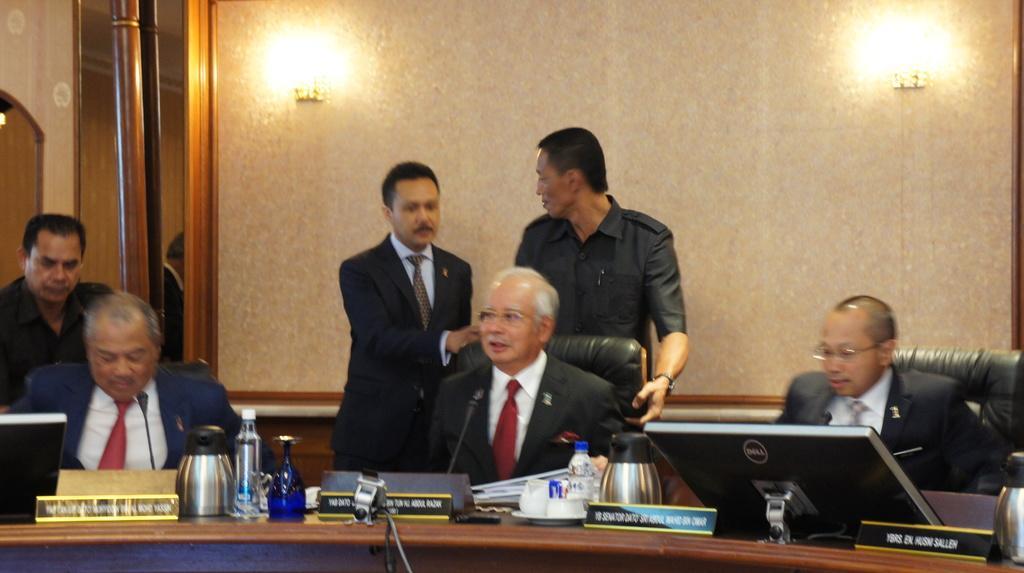Please provide a concise description of this image. In this image, at the right side we can see a black color monitor, we can see two microphones, there are some people sitting on the chairs, in the background there are two persons standing and there is a wall and we can see two lights on the wall. 